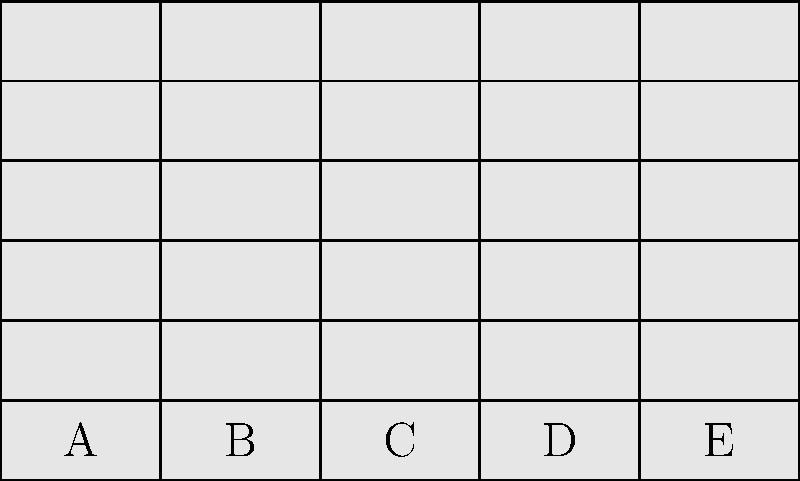In the storage room of Dunder Mifflin Paper Company, you need to arrange boxes of paper on a shelf as shown in the diagram. Each column (A, B, C, D, E) represents a different type of paper. If you need to add one more box of type C paper, which arrangement would maximize space efficiency? To maximize space efficiency when adding one more box of type C paper, we need to follow these steps:

1. Observe the current arrangement:
   Column A: 6 boxes
   Column B: 6 boxes
   Column C: 6 boxes
   Column D: 6 boxes
   Column E: 6 boxes

2. Adding one more box to column C would make it exceed the height of the shelf.

3. To maintain balance and maximize space efficiency, we should redistribute the boxes:
   a. Move one box from column C to column D
   b. Move one box from column D to column E
   c. Add the new box to column C

4. The resulting arrangement would be:
   Column A: 6 boxes
   Column B: 6 boxes
   Column C: 6 boxes (5 original + 1 new)
   Column D: 6 boxes (5 original from D + 1 from C)
   Column E: 7 boxes (6 original + 1 from D)

5. This arrangement ensures that all columns are filled to capacity, with only column E slightly higher, maximizing the use of available space.

As Dwight Schrute would say, "Whenever I'm about to do something, I think, 'Would an idiot do that?' And if they would, I do not do that thing." In this case, an idiot would simply stack the new box on top of column C, but we're smarter than that!
Answer: Move 1 box from C to D, 1 from D to E, add new box to C 